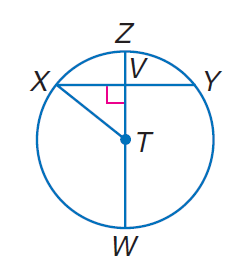Question: In \odot T, Z V = 1, and T W = 13. Find X V.
Choices:
A. 5
B. 11
C. 12
D. 13
Answer with the letter. Answer: A 